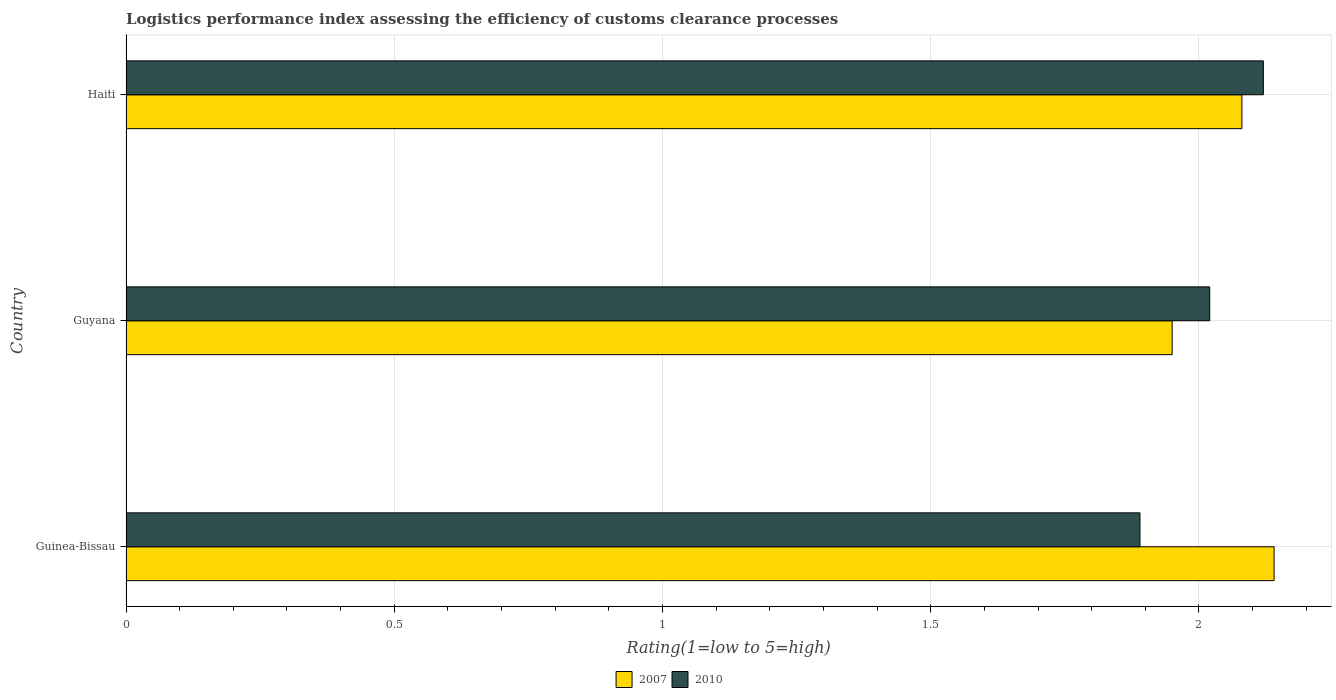How many different coloured bars are there?
Your answer should be compact. 2. How many groups of bars are there?
Provide a succinct answer. 3. What is the label of the 3rd group of bars from the top?
Make the answer very short. Guinea-Bissau. What is the Logistic performance index in 2010 in Haiti?
Keep it short and to the point. 2.12. Across all countries, what is the maximum Logistic performance index in 2010?
Offer a very short reply. 2.12. Across all countries, what is the minimum Logistic performance index in 2007?
Provide a short and direct response. 1.95. In which country was the Logistic performance index in 2010 maximum?
Provide a succinct answer. Haiti. In which country was the Logistic performance index in 2007 minimum?
Your response must be concise. Guyana. What is the total Logistic performance index in 2007 in the graph?
Offer a very short reply. 6.17. What is the difference between the Logistic performance index in 2010 in Guinea-Bissau and that in Guyana?
Offer a very short reply. -0.13. What is the difference between the Logistic performance index in 2010 in Guyana and the Logistic performance index in 2007 in Haiti?
Make the answer very short. -0.06. What is the average Logistic performance index in 2010 per country?
Your response must be concise. 2.01. What is the difference between the Logistic performance index in 2010 and Logistic performance index in 2007 in Haiti?
Your response must be concise. 0.04. In how many countries, is the Logistic performance index in 2007 greater than 0.6 ?
Provide a succinct answer. 3. What is the ratio of the Logistic performance index in 2010 in Guinea-Bissau to that in Haiti?
Give a very brief answer. 0.89. Is the Logistic performance index in 2010 in Guyana less than that in Haiti?
Provide a succinct answer. Yes. What is the difference between the highest and the second highest Logistic performance index in 2007?
Offer a terse response. 0.06. What is the difference between the highest and the lowest Logistic performance index in 2010?
Your answer should be very brief. 0.23. What does the 2nd bar from the bottom in Haiti represents?
Your response must be concise. 2010. How many bars are there?
Offer a very short reply. 6. Does the graph contain any zero values?
Provide a short and direct response. No. Where does the legend appear in the graph?
Your answer should be compact. Bottom center. How many legend labels are there?
Give a very brief answer. 2. What is the title of the graph?
Make the answer very short. Logistics performance index assessing the efficiency of customs clearance processes. What is the label or title of the X-axis?
Your response must be concise. Rating(1=low to 5=high). What is the Rating(1=low to 5=high) in 2007 in Guinea-Bissau?
Provide a succinct answer. 2.14. What is the Rating(1=low to 5=high) of 2010 in Guinea-Bissau?
Your response must be concise. 1.89. What is the Rating(1=low to 5=high) in 2007 in Guyana?
Your answer should be very brief. 1.95. What is the Rating(1=low to 5=high) in 2010 in Guyana?
Make the answer very short. 2.02. What is the Rating(1=low to 5=high) in 2007 in Haiti?
Ensure brevity in your answer.  2.08. What is the Rating(1=low to 5=high) of 2010 in Haiti?
Ensure brevity in your answer.  2.12. Across all countries, what is the maximum Rating(1=low to 5=high) in 2007?
Your answer should be very brief. 2.14. Across all countries, what is the maximum Rating(1=low to 5=high) in 2010?
Your response must be concise. 2.12. Across all countries, what is the minimum Rating(1=low to 5=high) of 2007?
Offer a very short reply. 1.95. Across all countries, what is the minimum Rating(1=low to 5=high) in 2010?
Keep it short and to the point. 1.89. What is the total Rating(1=low to 5=high) in 2007 in the graph?
Your answer should be compact. 6.17. What is the total Rating(1=low to 5=high) in 2010 in the graph?
Provide a short and direct response. 6.03. What is the difference between the Rating(1=low to 5=high) in 2007 in Guinea-Bissau and that in Guyana?
Make the answer very short. 0.19. What is the difference between the Rating(1=low to 5=high) in 2010 in Guinea-Bissau and that in Guyana?
Your answer should be compact. -0.13. What is the difference between the Rating(1=low to 5=high) in 2010 in Guinea-Bissau and that in Haiti?
Your response must be concise. -0.23. What is the difference between the Rating(1=low to 5=high) in 2007 in Guyana and that in Haiti?
Provide a succinct answer. -0.13. What is the difference between the Rating(1=low to 5=high) in 2010 in Guyana and that in Haiti?
Provide a short and direct response. -0.1. What is the difference between the Rating(1=low to 5=high) of 2007 in Guinea-Bissau and the Rating(1=low to 5=high) of 2010 in Guyana?
Provide a short and direct response. 0.12. What is the difference between the Rating(1=low to 5=high) in 2007 in Guyana and the Rating(1=low to 5=high) in 2010 in Haiti?
Make the answer very short. -0.17. What is the average Rating(1=low to 5=high) of 2007 per country?
Give a very brief answer. 2.06. What is the average Rating(1=low to 5=high) in 2010 per country?
Give a very brief answer. 2.01. What is the difference between the Rating(1=low to 5=high) in 2007 and Rating(1=low to 5=high) in 2010 in Guyana?
Keep it short and to the point. -0.07. What is the difference between the Rating(1=low to 5=high) of 2007 and Rating(1=low to 5=high) of 2010 in Haiti?
Offer a very short reply. -0.04. What is the ratio of the Rating(1=low to 5=high) of 2007 in Guinea-Bissau to that in Guyana?
Ensure brevity in your answer.  1.1. What is the ratio of the Rating(1=low to 5=high) of 2010 in Guinea-Bissau to that in Guyana?
Your answer should be compact. 0.94. What is the ratio of the Rating(1=low to 5=high) in 2007 in Guinea-Bissau to that in Haiti?
Offer a very short reply. 1.03. What is the ratio of the Rating(1=low to 5=high) in 2010 in Guinea-Bissau to that in Haiti?
Keep it short and to the point. 0.89. What is the ratio of the Rating(1=low to 5=high) of 2010 in Guyana to that in Haiti?
Keep it short and to the point. 0.95. What is the difference between the highest and the lowest Rating(1=low to 5=high) in 2007?
Offer a terse response. 0.19. What is the difference between the highest and the lowest Rating(1=low to 5=high) of 2010?
Your answer should be compact. 0.23. 